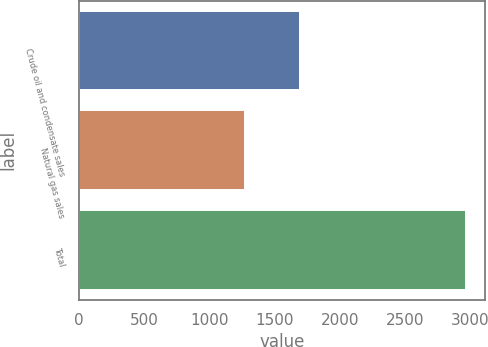Convert chart to OTSL. <chart><loc_0><loc_0><loc_500><loc_500><bar_chart><fcel>Crude oil and condensate sales<fcel>Natural gas sales<fcel>Total<nl><fcel>1694<fcel>1272<fcel>2966<nl></chart> 